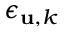Convert formula to latex. <formula><loc_0><loc_0><loc_500><loc_500>\epsilon _ { { u } , k }</formula> 